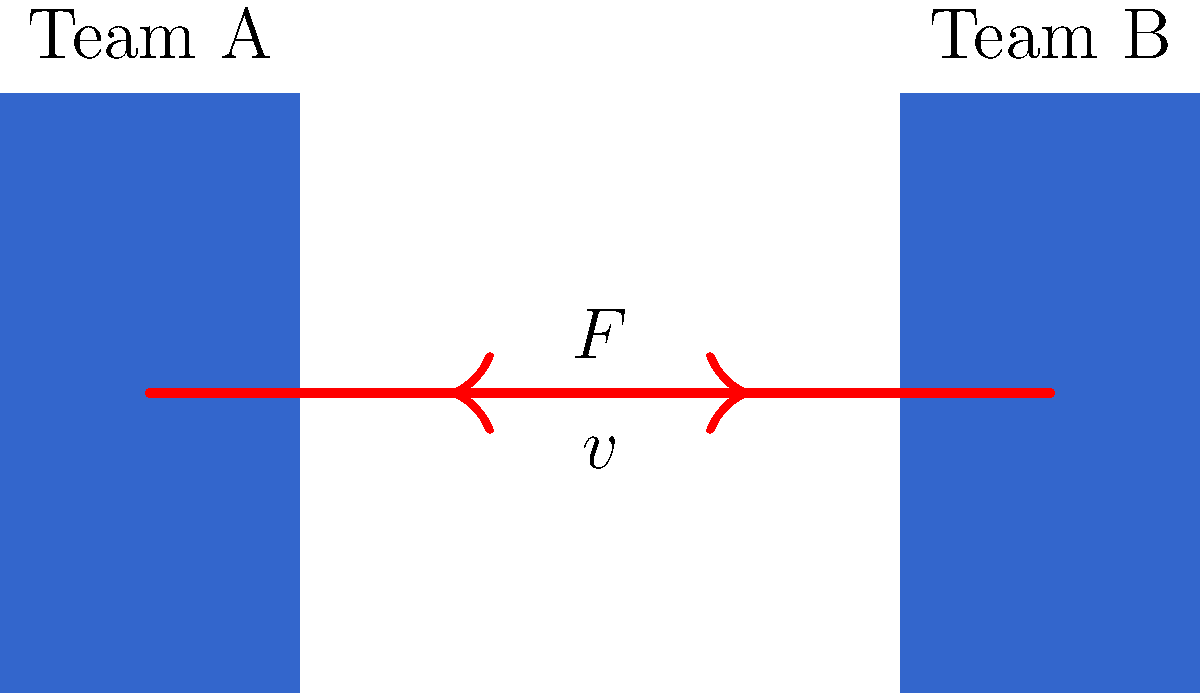In a rugby scrum, Team A (mass 800 kg) engages Team B (mass 820 kg) with an initial velocity of 2 m/s. If the teams exert equal and opposite forces of 5000 N on each other for 0.5 seconds, what is the final velocity of Team A immediately after the scrum? Let's approach this step-by-step:

1) First, we need to calculate the initial momentum of Team A:
   $p_i = m_A v_i = 800 \text{ kg} \times 2 \text{ m/s} = 1600 \text{ kg}\cdot\text{m/s}$

2) Now, we need to find the impulse applied to Team A during the scrum:
   Impulse $= F \times t = 5000 \text{ N} \times 0.5 \text{ s} = 2500 \text{ N}\cdot\text{s}$

3) The impulse-momentum theorem states that the change in momentum equals the impulse:
   $\Delta p = F \times t$

4) We can find the change in momentum:
   $\Delta p = 2500 \text{ N}\cdot\text{s} = 2500 \text{ kg}\cdot\text{m/s}$

5) The final momentum will be:
   $p_f = p_i - \Delta p = 1600 - 2500 = -900 \text{ kg}\cdot\text{m/s}$

6) To find the final velocity, we use the equation:
   $v_f = \frac{p_f}{m_A} = \frac{-900 \text{ kg}\cdot\text{m/s}}{800 \text{ kg}} = -1.125 \text{ m/s}$

The negative sign indicates that Team A is now moving in the opposite direction.
Answer: -1.125 m/s 